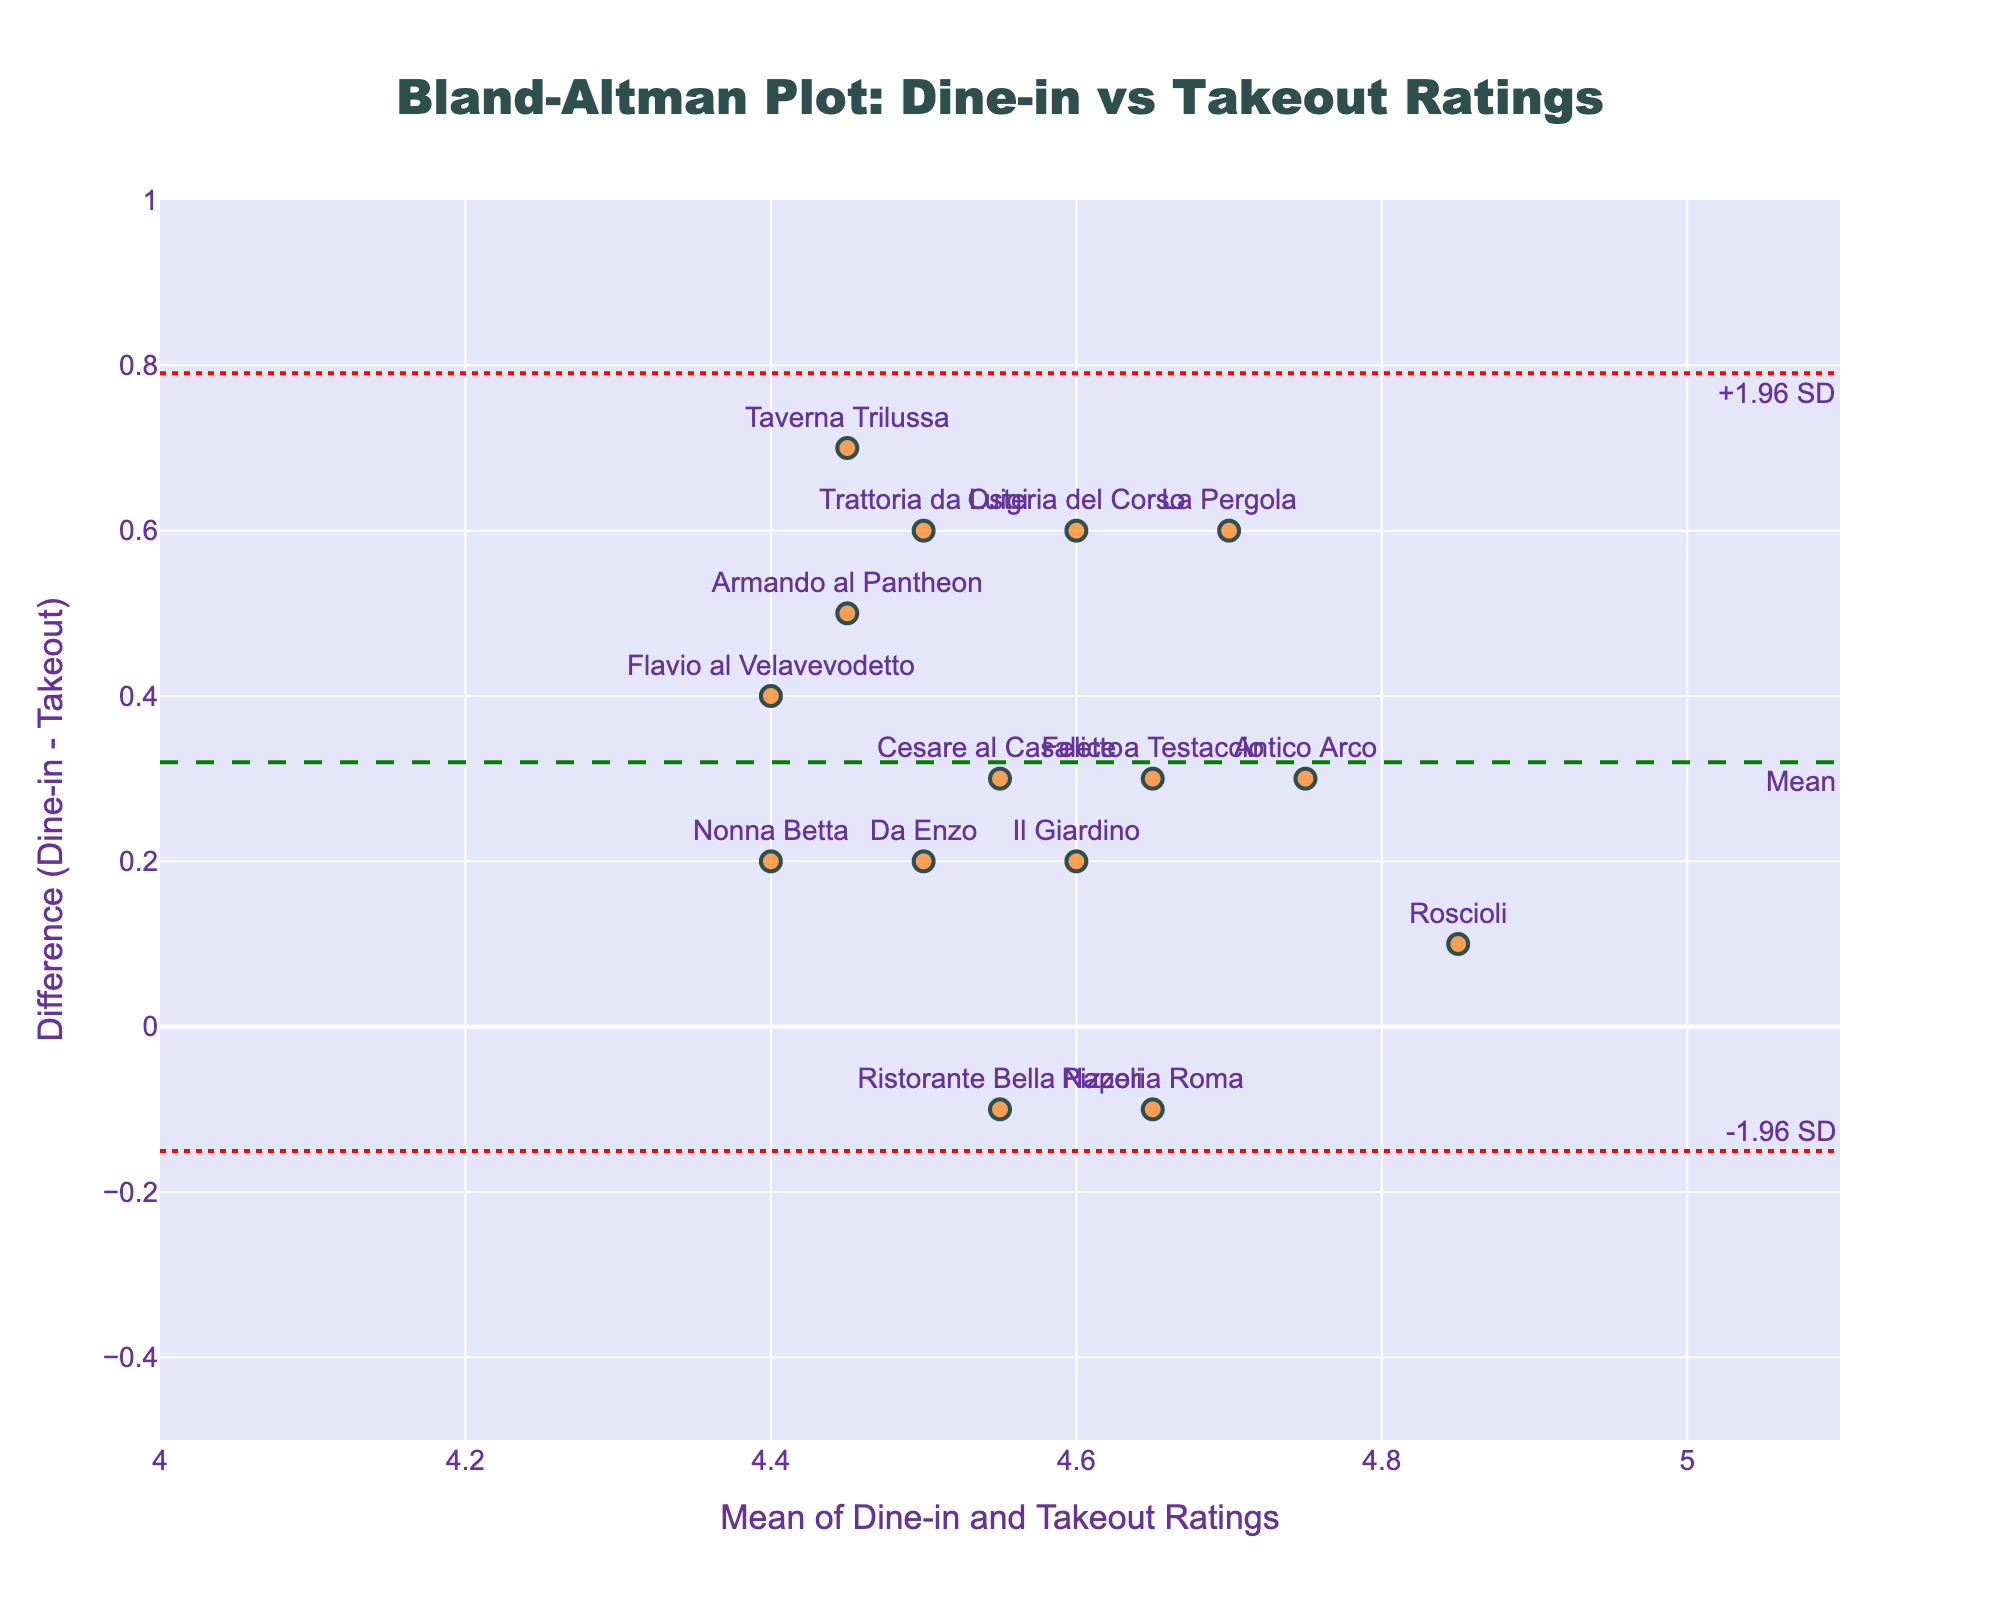What is the title of the plot? The title is displayed at the top center of the figure. It reads "Bland-Altman Plot: Dine-in vs Takeout Ratings."
Answer: Bland-Altman Plot: Dine-in vs Takeout Ratings What do the x-axis and y-axis represent? The x-axis represents the mean of the Dine-in and Takeout Ratings, while the y-axis represents the difference between the Dine-in and Takeout Ratings.
Answer: x-axis: Mean of Dine-in and Takeout Ratings, y-axis: Difference (Dine-in - Takeout) Which restaurant had the largest positive difference between Dine-in and Takeout ratings? Look at the highest data point on the y-axis (difference). The corresponding restaurant label is "Taverna Trilussa."
Answer: Taverna Trilussa What are the colors of the dot and horizontal lines in the plot? The dots are orange with a black outline, and the horizontal lines are green for the mean and red for the limits of agreement.
Answer: Dots: orange with black outlines, mean line: green, limits of agreement: red What is the range of the y-axis? The y-axis range is from -0.5 to 1, as indicated by the ticks and limits of the axis.
Answer: -0.5 to 1 What are the values of the limits of agreement (+1.96 SD and -1.96 SD)? These values can be read directly from the plot. The upper limit is approximately 0.65, and the lower limit is approximately -0.05.
Answer: +0.65 and -0.05 Which restaurant had the closest Dine-in and Takeout ratings? The restaurant closest to the zero line on the y-axis (difference = 0) is "Roscioli."
Answer: Roscioli How many restaurants displayed a positive difference in ratings? Count the number of dots above the zero line on the y-axis. There are 10 restaurants with a positive difference.
Answer: 10 How is the mean difference represented in the plot, and what is its approximate value? The mean difference is shown by the green dashed line on the y-axis. Its value is approximately 0.35.
Answer: Green dashed line, approximately 0.35 What does a positive difference in the ratings imply? A positive difference indicates that the Dine-in Rating is higher than the Takeout Rating for that restaurant.
Answer: Dine-in Rating > Takeout Rating 